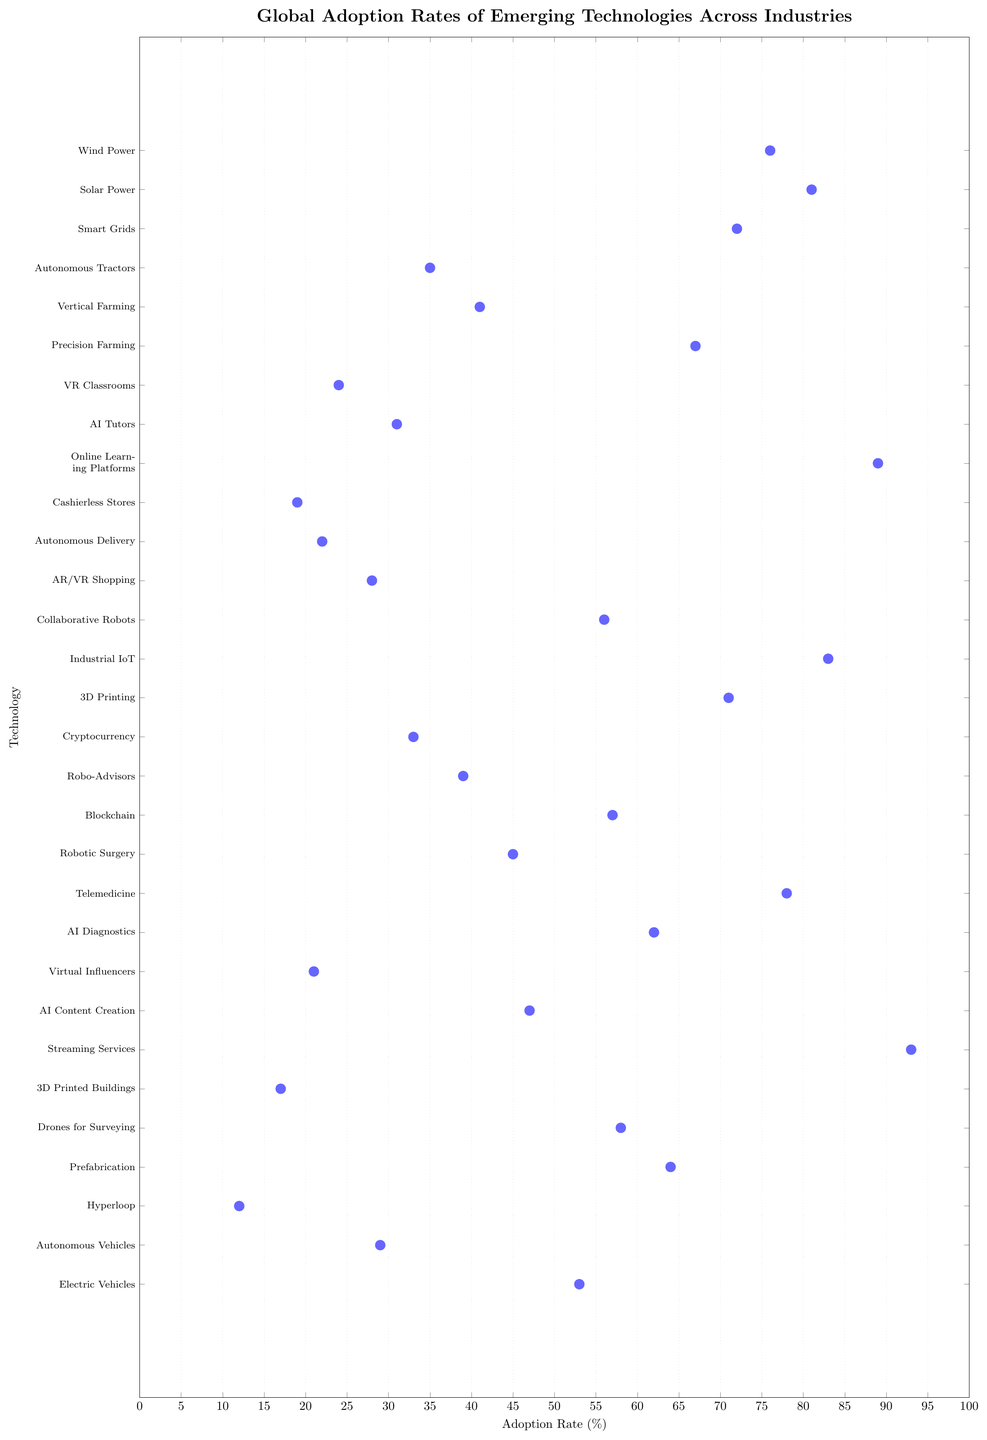What is the adoption rate of Telemedicine in the Healthcare industry? The adoption rate of Telemedicine can be found in the Healthcare section on the y-axis. Look at the dot corresponding to Telemedicine and read the x-axis value next to it.
Answer: 78% Which technology in the Energy sector has the highest adoption rate? The technologies within the Energy sector are listed as Wind Power, Solar Power, and Smart Grids. Check the dots corresponding to these technologies and compare their adoption rates.
Answer: Solar Power Which industry has the lowest average adoption rate across its listed technologies? Calculate the average adoption rate for each industry by summing the rates for their respective technologies and dividing by the number of those technologies. Compare the averages.
Answer: Retail How does the adoption rate of Autonomous Delivery in Retail compare to the adoption rate of Electric Vehicles in Transportation? Identify the adoption rates for both Autonomous Delivery (Retail) and Electric Vehicles (Transportation). Compare these two values.
Answer: Electric Vehicles > Autonomous Delivery What is the combined adoption rate of AI Diagnostics and Robotic Surgery in Healthcare? Find the adoption rates for AI Diagnostics and Robotic Surgery in the Healthcare sector, then sum these two values.
Answer: 107% Which technology across all industries has an adoption rate closest to 50%? Look at all the dots on the plot and identify the one with an x-axis value closest to 50%.
Answer: Electric Vehicles Which sector dominates the Technologies with adoption rates above 70%? Identify all technologies with rates above 70%. Check which sector they belong to and count the occurrences for each sector.
Answer: Energy Compare the adoption rates of AI Tutors and VR Classrooms in the Education industry. Which one is higher? Locate AI Tutors and VR Classrooms in the Education sector and compare their corresponding adoption rates.
Answer: AI Tutors What is the rate difference between the highest and lowest adoption technology in the Finance sector? Identify the maximum and minimum adoption rates in the Finance sector by comparing the values for Blockchain, Robo-Advisors, and Cryptocurrency. Subtract the minimum rate from the maximum rate.
Answer: 24% Which technology in the Construction sector has the lowest adoption rate? Locate all the technologies in the Construction sector and identify the one with the lowest adoption rate by comparing their values.
Answer: 3D Printed Buildings 